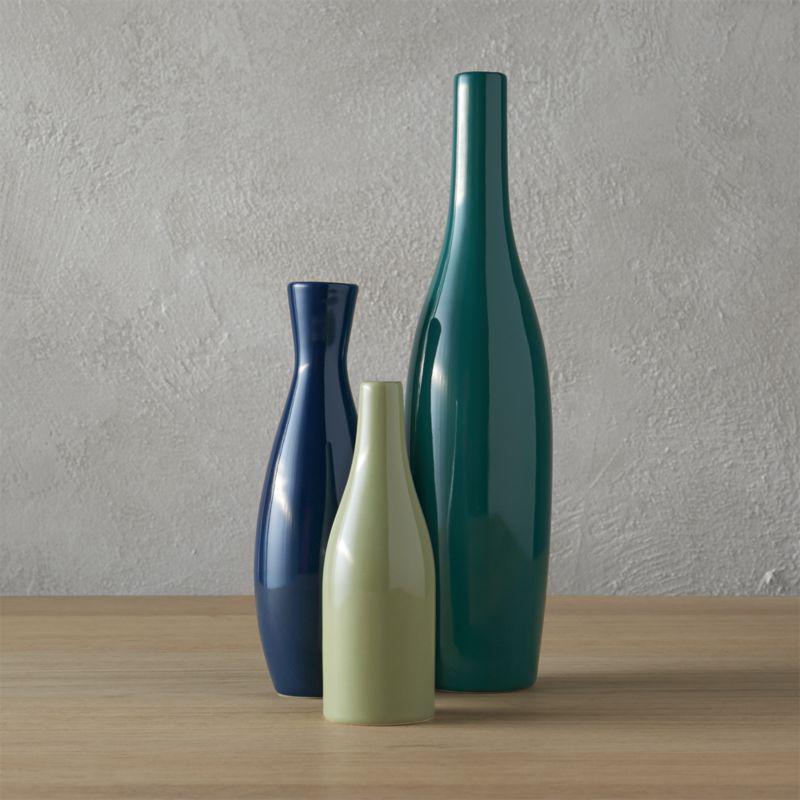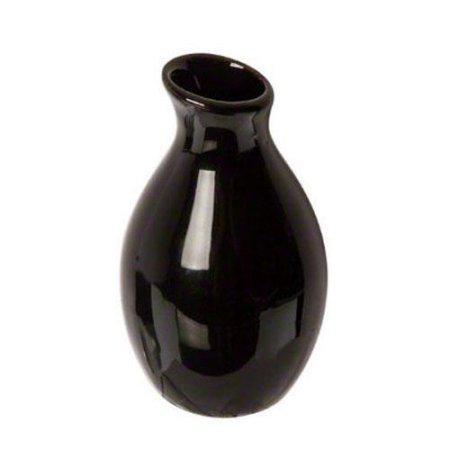The first image is the image on the left, the second image is the image on the right. Evaluate the accuracy of this statement regarding the images: "Each image contains one container, and each container is curvy.". Is it true? Answer yes or no. No. 